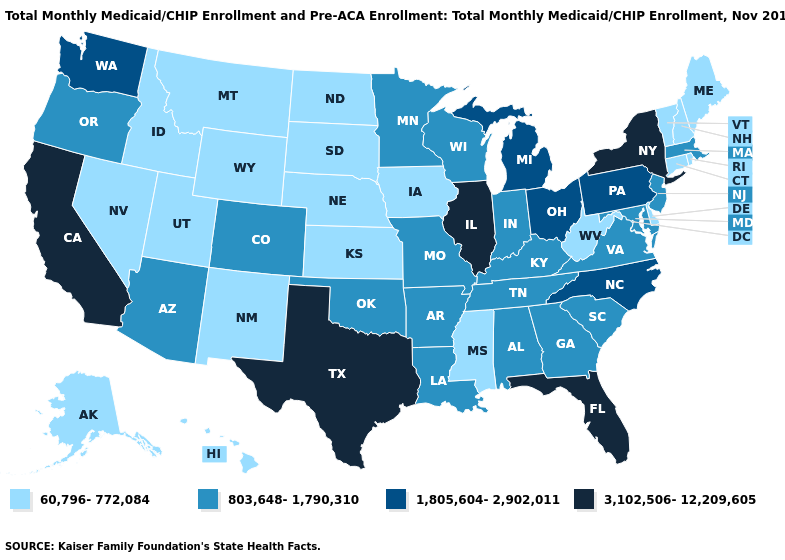What is the lowest value in the USA?
Write a very short answer. 60,796-772,084. Does the map have missing data?
Give a very brief answer. No. Name the states that have a value in the range 803,648-1,790,310?
Keep it brief. Alabama, Arizona, Arkansas, Colorado, Georgia, Indiana, Kentucky, Louisiana, Maryland, Massachusetts, Minnesota, Missouri, New Jersey, Oklahoma, Oregon, South Carolina, Tennessee, Virginia, Wisconsin. What is the value of Alaska?
Give a very brief answer. 60,796-772,084. What is the value of Kentucky?
Quick response, please. 803,648-1,790,310. Does Texas have the highest value in the South?
Answer briefly. Yes. How many symbols are there in the legend?
Be succinct. 4. What is the value of Missouri?
Concise answer only. 803,648-1,790,310. Which states have the lowest value in the South?
Quick response, please. Delaware, Mississippi, West Virginia. Name the states that have a value in the range 1,805,604-2,902,011?
Write a very short answer. Michigan, North Carolina, Ohio, Pennsylvania, Washington. Name the states that have a value in the range 803,648-1,790,310?
Write a very short answer. Alabama, Arizona, Arkansas, Colorado, Georgia, Indiana, Kentucky, Louisiana, Maryland, Massachusetts, Minnesota, Missouri, New Jersey, Oklahoma, Oregon, South Carolina, Tennessee, Virginia, Wisconsin. Among the states that border Connecticut , which have the lowest value?
Give a very brief answer. Rhode Island. Among the states that border Idaho , which have the lowest value?
Answer briefly. Montana, Nevada, Utah, Wyoming. What is the value of Pennsylvania?
Answer briefly. 1,805,604-2,902,011. Name the states that have a value in the range 3,102,506-12,209,605?
Answer briefly. California, Florida, Illinois, New York, Texas. 